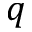Convert formula to latex. <formula><loc_0><loc_0><loc_500><loc_500>q</formula> 